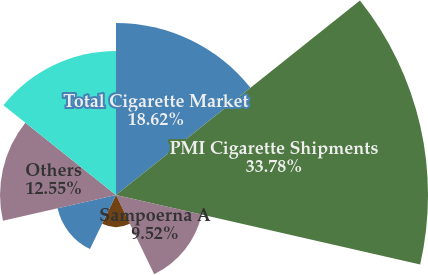<chart> <loc_0><loc_0><loc_500><loc_500><pie_chart><fcel>Total Cigarette Market<fcel>PMI Cigarette Shipments<fcel>Sampoerna A<fcel>Dji Sam Soe<fcel>U Mild<fcel>Others<fcel>Total<nl><fcel>18.61%<fcel>33.77%<fcel>9.52%<fcel>3.46%<fcel>6.49%<fcel>12.55%<fcel>15.58%<nl></chart> 